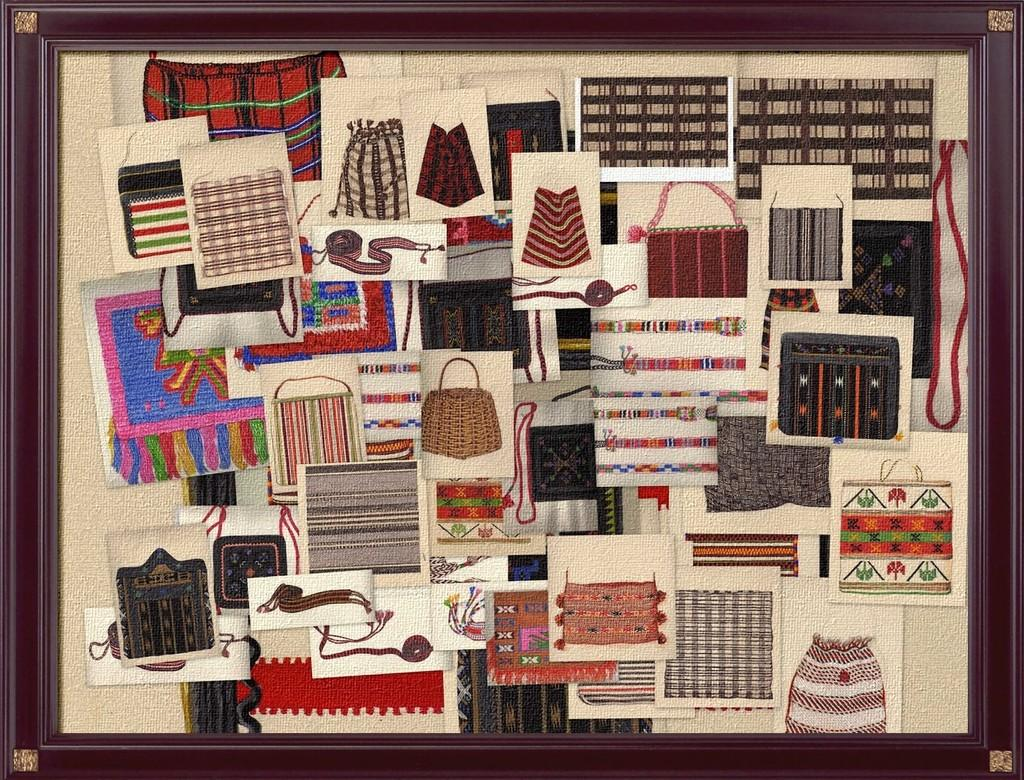What is the main subject of the image? The main subject of the image is a frame. What can be found inside the frame? There are arts within the frame. Is there a bridge visible in the image? No, there is no bridge present in the image. The image only contains a frame with arts inside it. 